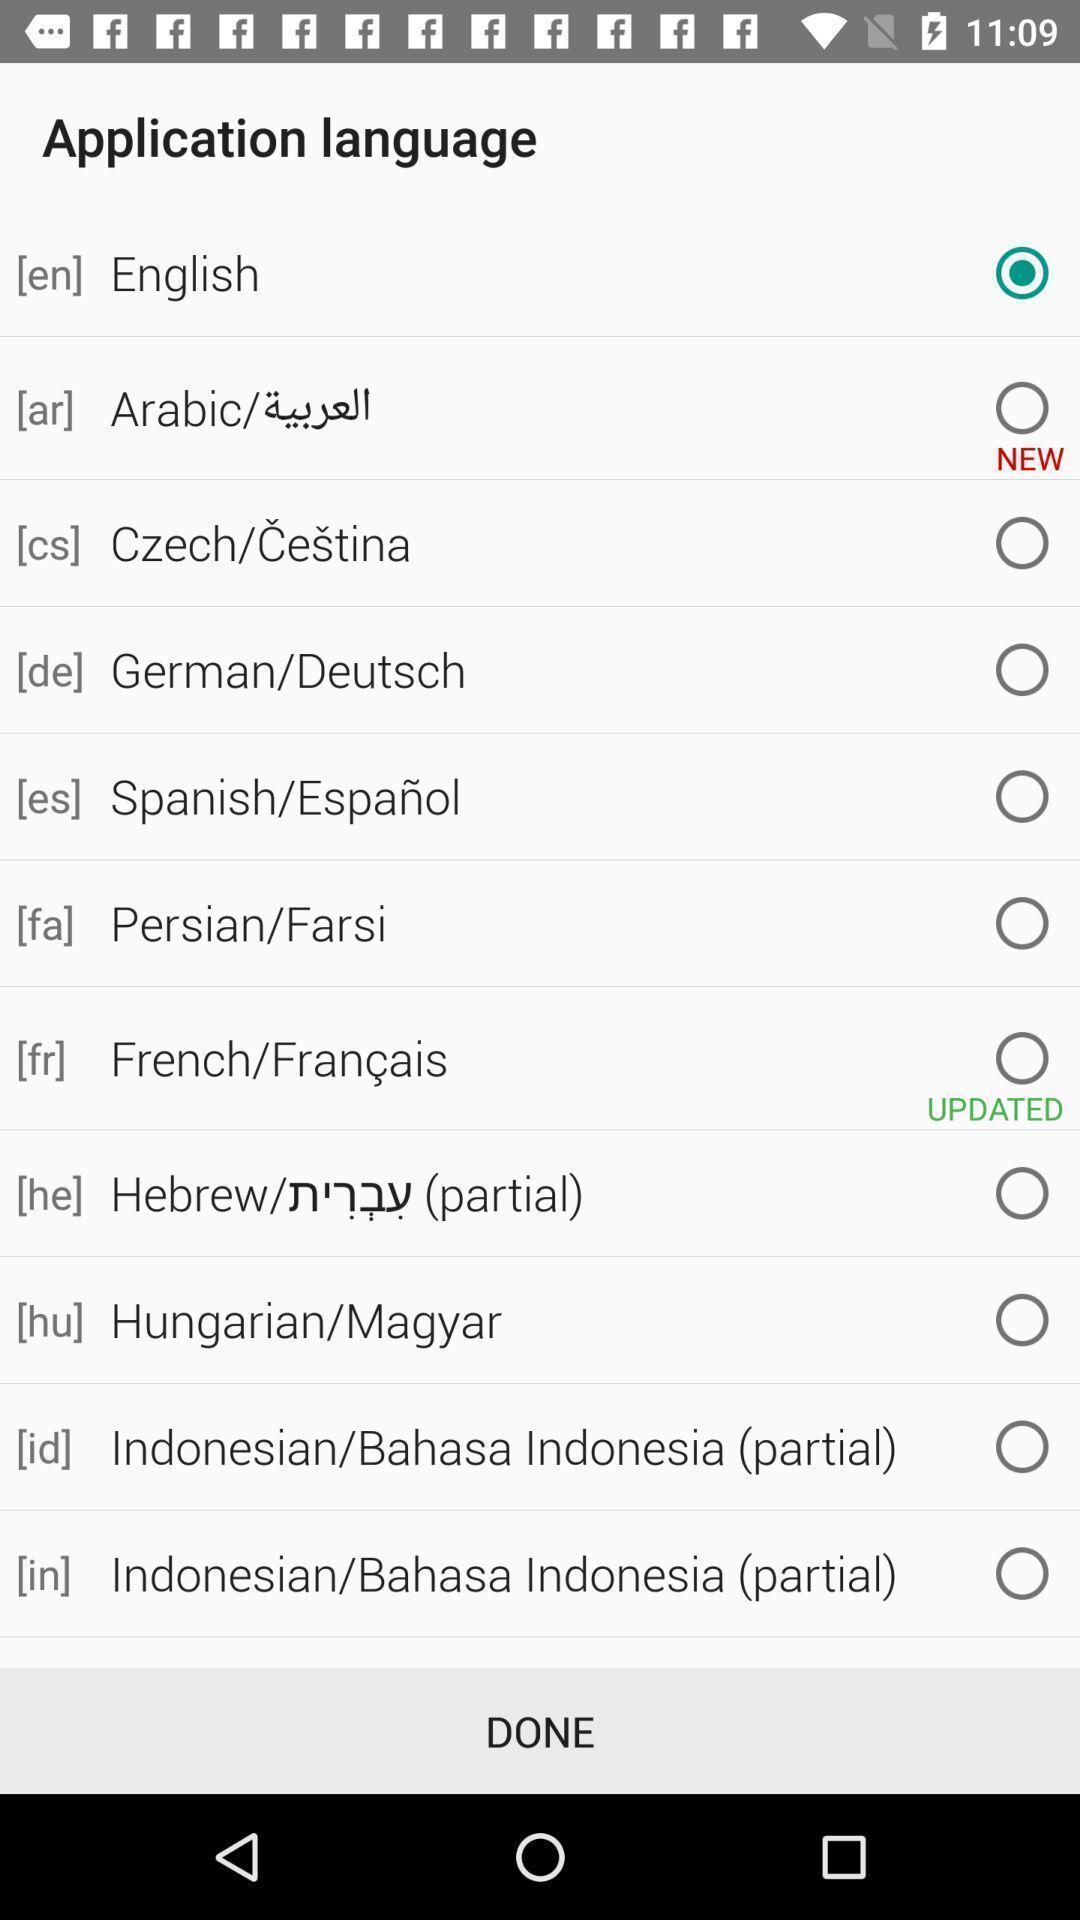Summarize the information in this screenshot. Screen displaying list of languages. 